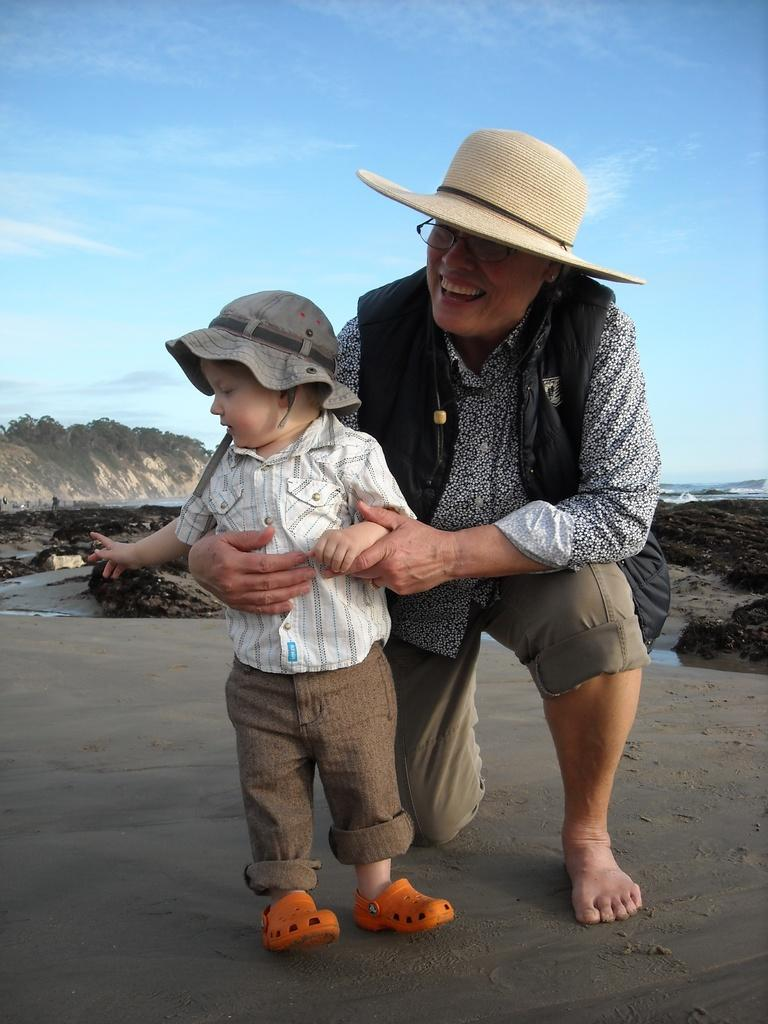How many people are in the image? There are two people in the image. What are the people wearing? The people are wearing different color dresses and hats. What can be seen in the background of the image? There are rocky mountains, clouds, and the sky visible in the background. What type of mark can be seen on the land in the image? There is no mark on the land visible in the image. Is there a market in the image? There is no market present in the image. 